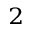Convert formula to latex. <formula><loc_0><loc_0><loc_500><loc_500>^ { 2 }</formula> 